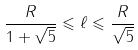<formula> <loc_0><loc_0><loc_500><loc_500>\frac { R } { 1 + \sqrt { 5 } } \leqslant \ell \leqslant \frac { R } { \sqrt { 5 } }</formula> 